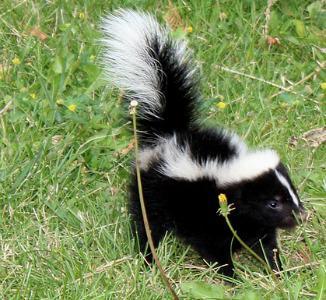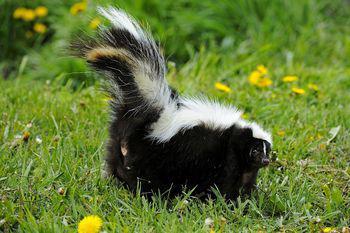The first image is the image on the left, the second image is the image on the right. Evaluate the accuracy of this statement regarding the images: "Both skunks are facing right.". Is it true? Answer yes or no. Yes. The first image is the image on the left, the second image is the image on the right. Analyze the images presented: Is the assertion "there is a skunk in the grass with dandelions growing in the grass" valid? Answer yes or no. Yes. 